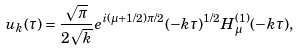<formula> <loc_0><loc_0><loc_500><loc_500>u _ { k } ( \tau ) = \frac { \sqrt { \pi } } { 2 \sqrt { k } } e ^ { i ( \mu + 1 / 2 ) \pi / 2 } ( - k \tau ) ^ { 1 / 2 } H ^ { ( 1 ) } _ { \mu } ( - k \tau ) ,</formula> 